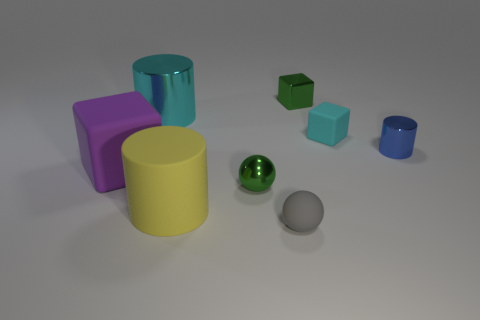How many other objects are there of the same color as the tiny shiny block?
Offer a terse response. 1. Is the material of the large purple cube the same as the cyan thing that is left of the small green block?
Provide a short and direct response. No. How many objects are either large things that are in front of the purple thing or big cyan metal objects?
Make the answer very short. 2. What is the shape of the rubber thing that is both behind the yellow cylinder and on the left side of the tiny green ball?
Give a very brief answer. Cube. Is there anything else that has the same size as the cyan matte object?
Provide a short and direct response. Yes. The green block that is the same material as the cyan cylinder is what size?
Offer a terse response. Small. What number of objects are cylinders that are behind the big purple matte cube or big yellow matte cylinders on the left side of the green cube?
Your answer should be very brief. 3. Is the size of the metal thing that is left of the yellow thing the same as the tiny gray ball?
Ensure brevity in your answer.  No. There is a sphere that is in front of the yellow rubber thing; what color is it?
Your response must be concise. Gray. There is a tiny thing that is the same shape as the big cyan shiny object; what is its color?
Give a very brief answer. Blue. 